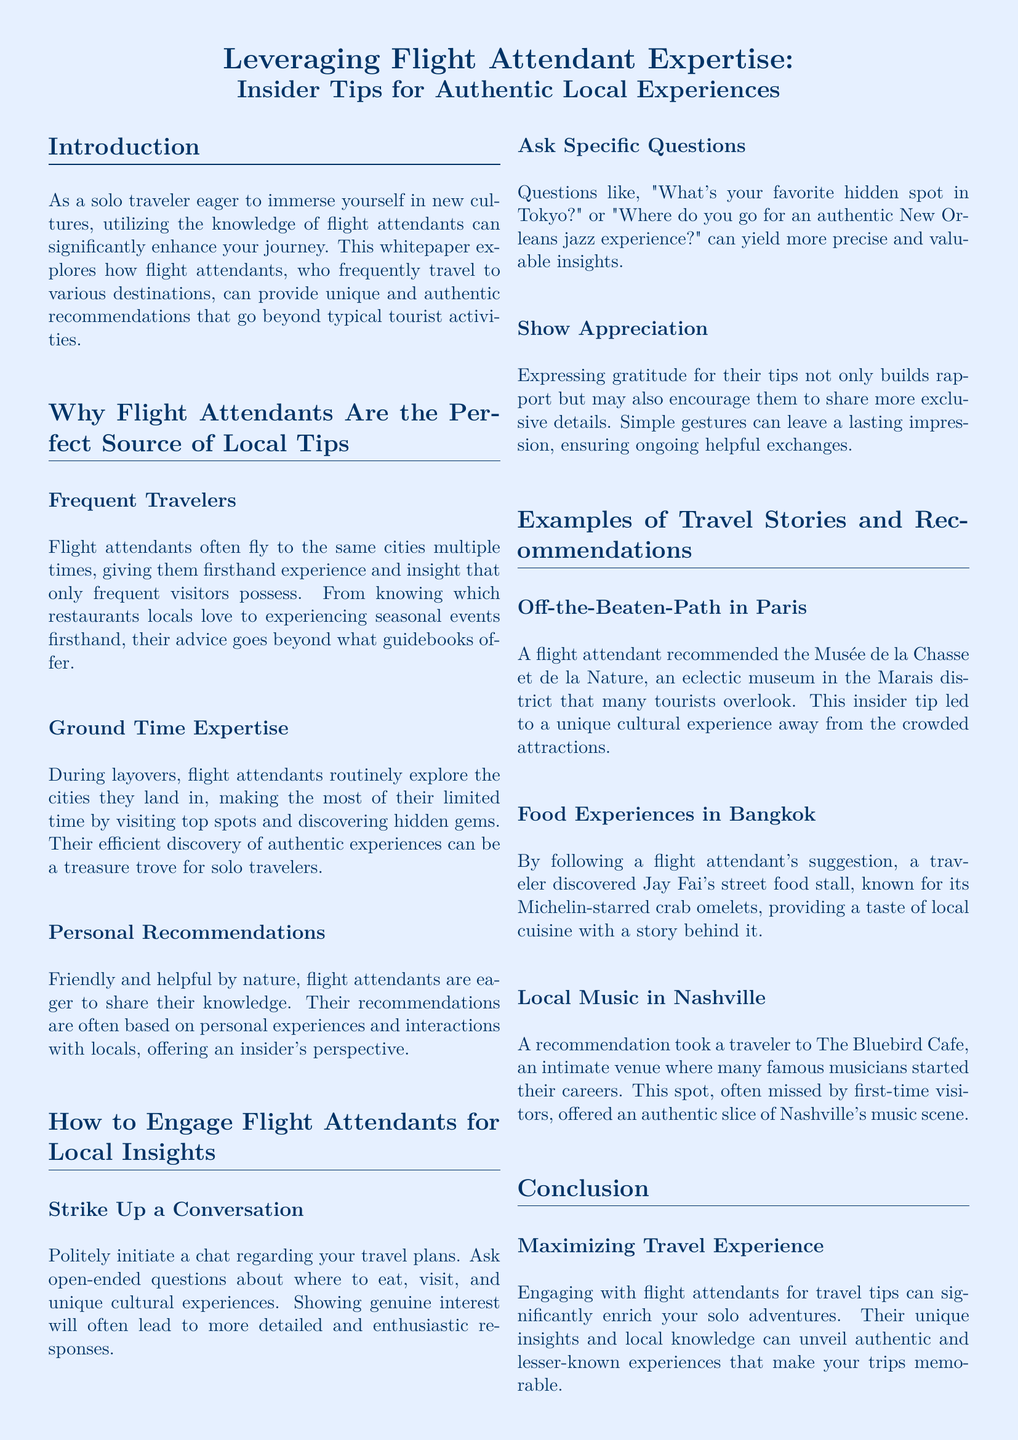What is the title of the whitepaper? The title is prominently displayed at the beginning of the document, stating the focus of the content.
Answer: Leveraging Flight Attendant Expertise: Insider Tips for Authentic Local Experiences What is one way flight attendants gain insights into cities? The document explains that flight attendants explore cities during layovers, which allows them to gather firsthand experiences.
Answer: Ground Time Expertise What is a recommended location to visit in Paris? An example from the document highlights a lesser-known cultural site recommended by a flight attendant.
Answer: Musée de la Chasse et de la Nature What type of cuisine is suggested in Bangkok? A specific food experience from the document showcases a unique local dish highlighted by a flight attendant.
Answer: Michelin-starred crab omelets What is the purpose of engaging with flight attendants according to the document? The conclusion emphasizes the benefits of traveler interactions with flight attendants in enhancing travel experiences.
Answer: Maximizing Travel Experience What type of questions should you ask flight attendants for better insights? The document suggests a strategy for inquiry that would yield valuable recommendations and insights.
Answer: Specific Questions 